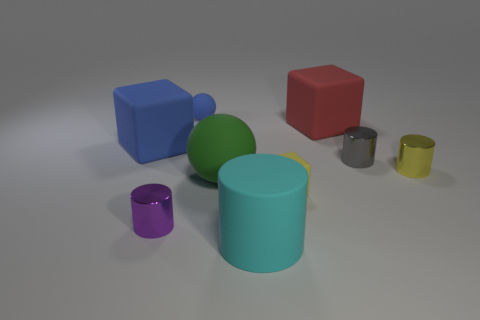Subtract all small gray cylinders. How many cylinders are left? 3 Subtract all cyan cylinders. How many cylinders are left? 3 Subtract 1 cubes. How many cubes are left? 2 Subtract all balls. How many objects are left? 7 Subtract 1 purple cylinders. How many objects are left? 8 Subtract all brown cubes. Subtract all cyan cylinders. How many cubes are left? 3 Subtract all brown spheres. How many blue blocks are left? 1 Subtract all big rubber cylinders. Subtract all gray metal things. How many objects are left? 7 Add 3 big cylinders. How many big cylinders are left? 4 Add 7 large blue shiny balls. How many large blue shiny balls exist? 7 